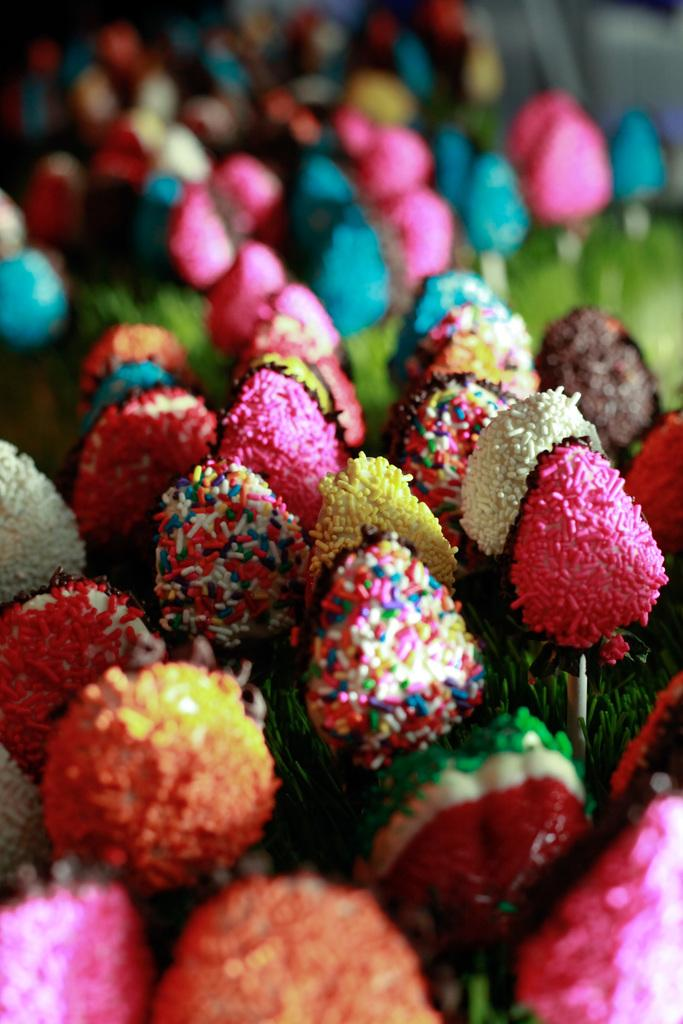What type of food items are present in the image? There are candies in the image. Can you describe the appearance of the candies? The candies are colorful. What can be observed about the background of the image? The background of the image is blurred. What type of hope can be seen in the image? There is no hope present in the image; it features colorful candies and a blurred background. What type of belief is represented by the candies in the image? The image does not depict any beliefs; it simply shows colorful candies and a blurred background. 